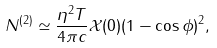<formula> <loc_0><loc_0><loc_500><loc_500>N ^ { ( 2 ) } \simeq \frac { \eta ^ { 2 } T } { 4 \pi c } \mathcal { X } ( 0 ) ( 1 - \cos \phi ) ^ { 2 } ,</formula> 